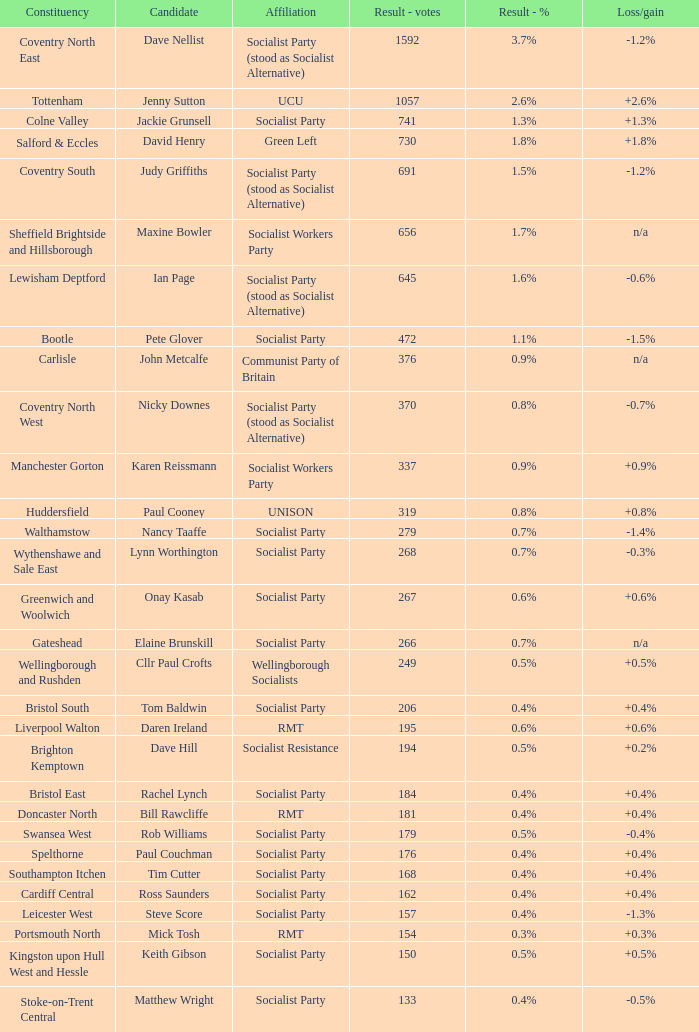What are the various affiliations linked to the tottenham constituency? UCU. 